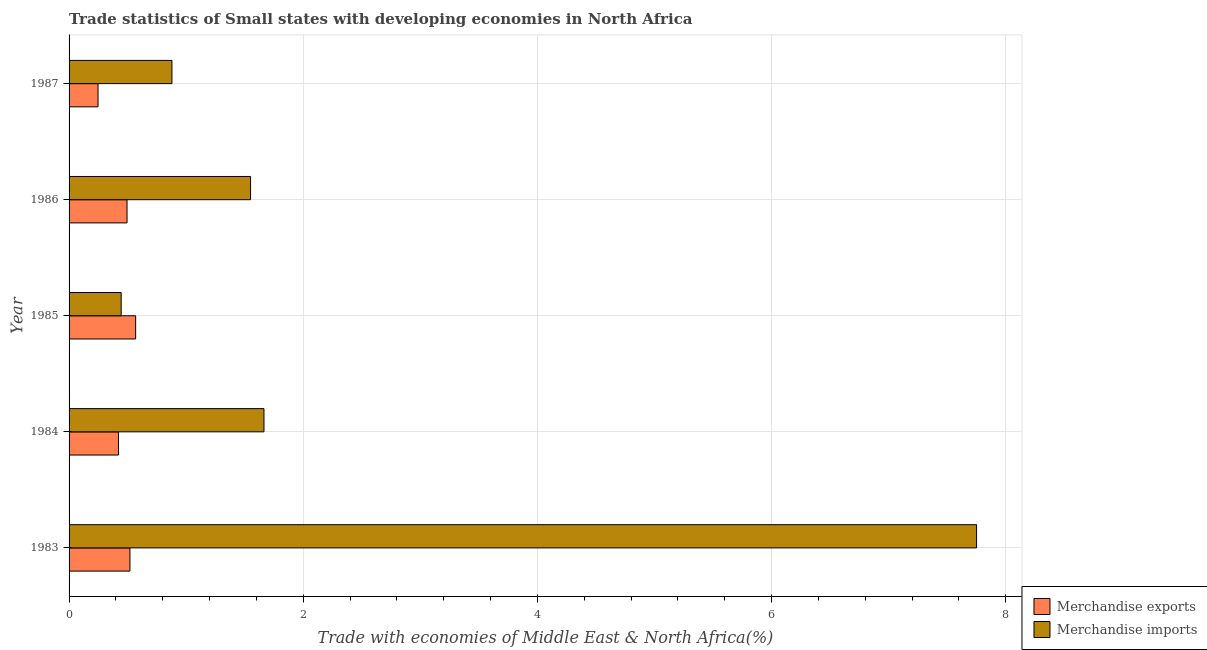How many groups of bars are there?
Offer a very short reply. 5. How many bars are there on the 2nd tick from the bottom?
Keep it short and to the point. 2. What is the label of the 4th group of bars from the top?
Ensure brevity in your answer.  1984. In how many cases, is the number of bars for a given year not equal to the number of legend labels?
Ensure brevity in your answer.  0. What is the merchandise imports in 1987?
Your answer should be compact. 0.88. Across all years, what is the maximum merchandise imports?
Your answer should be very brief. 7.75. Across all years, what is the minimum merchandise imports?
Offer a terse response. 0.45. In which year was the merchandise exports minimum?
Give a very brief answer. 1987. What is the total merchandise exports in the graph?
Your response must be concise. 2.25. What is the difference between the merchandise exports in 1984 and that in 1985?
Provide a short and direct response. -0.15. What is the difference between the merchandise imports in 1984 and the merchandise exports in 1983?
Your answer should be very brief. 1.15. What is the average merchandise exports per year?
Your answer should be very brief. 0.45. In the year 1986, what is the difference between the merchandise imports and merchandise exports?
Give a very brief answer. 1.05. In how many years, is the merchandise exports greater than 1.2000000000000002 %?
Provide a succinct answer. 0. What is the ratio of the merchandise exports in 1983 to that in 1985?
Your answer should be compact. 0.91. What is the difference between the highest and the second highest merchandise imports?
Make the answer very short. 6.09. What is the difference between the highest and the lowest merchandise imports?
Provide a succinct answer. 7.31. What does the 2nd bar from the bottom in 1984 represents?
Your answer should be very brief. Merchandise imports. How many bars are there?
Provide a short and direct response. 10. Are all the bars in the graph horizontal?
Ensure brevity in your answer.  Yes. What is the difference between two consecutive major ticks on the X-axis?
Ensure brevity in your answer.  2. Where does the legend appear in the graph?
Your answer should be very brief. Bottom right. How many legend labels are there?
Provide a short and direct response. 2. What is the title of the graph?
Offer a very short reply. Trade statistics of Small states with developing economies in North Africa. What is the label or title of the X-axis?
Offer a very short reply. Trade with economies of Middle East & North Africa(%). What is the Trade with economies of Middle East & North Africa(%) in Merchandise exports in 1983?
Make the answer very short. 0.52. What is the Trade with economies of Middle East & North Africa(%) in Merchandise imports in 1983?
Your answer should be very brief. 7.75. What is the Trade with economies of Middle East & North Africa(%) in Merchandise exports in 1984?
Your answer should be very brief. 0.42. What is the Trade with economies of Middle East & North Africa(%) of Merchandise imports in 1984?
Make the answer very short. 1.66. What is the Trade with economies of Middle East & North Africa(%) of Merchandise exports in 1985?
Ensure brevity in your answer.  0.57. What is the Trade with economies of Middle East & North Africa(%) of Merchandise imports in 1985?
Give a very brief answer. 0.45. What is the Trade with economies of Middle East & North Africa(%) in Merchandise exports in 1986?
Offer a terse response. 0.5. What is the Trade with economies of Middle East & North Africa(%) in Merchandise imports in 1986?
Your answer should be compact. 1.55. What is the Trade with economies of Middle East & North Africa(%) of Merchandise exports in 1987?
Make the answer very short. 0.25. What is the Trade with economies of Middle East & North Africa(%) in Merchandise imports in 1987?
Make the answer very short. 0.88. Across all years, what is the maximum Trade with economies of Middle East & North Africa(%) of Merchandise exports?
Offer a terse response. 0.57. Across all years, what is the maximum Trade with economies of Middle East & North Africa(%) in Merchandise imports?
Your answer should be very brief. 7.75. Across all years, what is the minimum Trade with economies of Middle East & North Africa(%) in Merchandise exports?
Your answer should be very brief. 0.25. Across all years, what is the minimum Trade with economies of Middle East & North Africa(%) in Merchandise imports?
Make the answer very short. 0.45. What is the total Trade with economies of Middle East & North Africa(%) in Merchandise exports in the graph?
Your answer should be very brief. 2.25. What is the total Trade with economies of Middle East & North Africa(%) of Merchandise imports in the graph?
Provide a short and direct response. 12.29. What is the difference between the Trade with economies of Middle East & North Africa(%) in Merchandise exports in 1983 and that in 1984?
Offer a terse response. 0.1. What is the difference between the Trade with economies of Middle East & North Africa(%) of Merchandise imports in 1983 and that in 1984?
Your answer should be compact. 6.09. What is the difference between the Trade with economies of Middle East & North Africa(%) of Merchandise exports in 1983 and that in 1985?
Provide a succinct answer. -0.05. What is the difference between the Trade with economies of Middle East & North Africa(%) in Merchandise imports in 1983 and that in 1985?
Offer a very short reply. 7.31. What is the difference between the Trade with economies of Middle East & North Africa(%) in Merchandise exports in 1983 and that in 1986?
Make the answer very short. 0.02. What is the difference between the Trade with economies of Middle East & North Africa(%) of Merchandise imports in 1983 and that in 1986?
Your answer should be compact. 6.2. What is the difference between the Trade with economies of Middle East & North Africa(%) of Merchandise exports in 1983 and that in 1987?
Give a very brief answer. 0.27. What is the difference between the Trade with economies of Middle East & North Africa(%) of Merchandise imports in 1983 and that in 1987?
Your response must be concise. 6.87. What is the difference between the Trade with economies of Middle East & North Africa(%) in Merchandise exports in 1984 and that in 1985?
Your response must be concise. -0.15. What is the difference between the Trade with economies of Middle East & North Africa(%) in Merchandise imports in 1984 and that in 1985?
Offer a terse response. 1.22. What is the difference between the Trade with economies of Middle East & North Africa(%) in Merchandise exports in 1984 and that in 1986?
Offer a very short reply. -0.07. What is the difference between the Trade with economies of Middle East & North Africa(%) in Merchandise imports in 1984 and that in 1986?
Offer a terse response. 0.11. What is the difference between the Trade with economies of Middle East & North Africa(%) of Merchandise exports in 1984 and that in 1987?
Offer a very short reply. 0.17. What is the difference between the Trade with economies of Middle East & North Africa(%) of Merchandise imports in 1984 and that in 1987?
Keep it short and to the point. 0.79. What is the difference between the Trade with economies of Middle East & North Africa(%) in Merchandise exports in 1985 and that in 1986?
Your answer should be compact. 0.07. What is the difference between the Trade with economies of Middle East & North Africa(%) in Merchandise imports in 1985 and that in 1986?
Give a very brief answer. -1.11. What is the difference between the Trade with economies of Middle East & North Africa(%) of Merchandise exports in 1985 and that in 1987?
Give a very brief answer. 0.32. What is the difference between the Trade with economies of Middle East & North Africa(%) in Merchandise imports in 1985 and that in 1987?
Your answer should be very brief. -0.43. What is the difference between the Trade with economies of Middle East & North Africa(%) of Merchandise exports in 1986 and that in 1987?
Make the answer very short. 0.25. What is the difference between the Trade with economies of Middle East & North Africa(%) of Merchandise imports in 1986 and that in 1987?
Ensure brevity in your answer.  0.67. What is the difference between the Trade with economies of Middle East & North Africa(%) of Merchandise exports in 1983 and the Trade with economies of Middle East & North Africa(%) of Merchandise imports in 1984?
Offer a terse response. -1.15. What is the difference between the Trade with economies of Middle East & North Africa(%) in Merchandise exports in 1983 and the Trade with economies of Middle East & North Africa(%) in Merchandise imports in 1985?
Your answer should be very brief. 0.07. What is the difference between the Trade with economies of Middle East & North Africa(%) of Merchandise exports in 1983 and the Trade with economies of Middle East & North Africa(%) of Merchandise imports in 1986?
Your answer should be compact. -1.03. What is the difference between the Trade with economies of Middle East & North Africa(%) of Merchandise exports in 1983 and the Trade with economies of Middle East & North Africa(%) of Merchandise imports in 1987?
Provide a short and direct response. -0.36. What is the difference between the Trade with economies of Middle East & North Africa(%) of Merchandise exports in 1984 and the Trade with economies of Middle East & North Africa(%) of Merchandise imports in 1985?
Your response must be concise. -0.02. What is the difference between the Trade with economies of Middle East & North Africa(%) in Merchandise exports in 1984 and the Trade with economies of Middle East & North Africa(%) in Merchandise imports in 1986?
Provide a short and direct response. -1.13. What is the difference between the Trade with economies of Middle East & North Africa(%) of Merchandise exports in 1984 and the Trade with economies of Middle East & North Africa(%) of Merchandise imports in 1987?
Make the answer very short. -0.46. What is the difference between the Trade with economies of Middle East & North Africa(%) in Merchandise exports in 1985 and the Trade with economies of Middle East & North Africa(%) in Merchandise imports in 1986?
Provide a short and direct response. -0.98. What is the difference between the Trade with economies of Middle East & North Africa(%) of Merchandise exports in 1985 and the Trade with economies of Middle East & North Africa(%) of Merchandise imports in 1987?
Ensure brevity in your answer.  -0.31. What is the difference between the Trade with economies of Middle East & North Africa(%) of Merchandise exports in 1986 and the Trade with economies of Middle East & North Africa(%) of Merchandise imports in 1987?
Provide a short and direct response. -0.38. What is the average Trade with economies of Middle East & North Africa(%) in Merchandise exports per year?
Your answer should be compact. 0.45. What is the average Trade with economies of Middle East & North Africa(%) in Merchandise imports per year?
Provide a short and direct response. 2.46. In the year 1983, what is the difference between the Trade with economies of Middle East & North Africa(%) of Merchandise exports and Trade with economies of Middle East & North Africa(%) of Merchandise imports?
Provide a short and direct response. -7.23. In the year 1984, what is the difference between the Trade with economies of Middle East & North Africa(%) in Merchandise exports and Trade with economies of Middle East & North Africa(%) in Merchandise imports?
Offer a terse response. -1.24. In the year 1985, what is the difference between the Trade with economies of Middle East & North Africa(%) of Merchandise exports and Trade with economies of Middle East & North Africa(%) of Merchandise imports?
Your answer should be very brief. 0.12. In the year 1986, what is the difference between the Trade with economies of Middle East & North Africa(%) of Merchandise exports and Trade with economies of Middle East & North Africa(%) of Merchandise imports?
Offer a very short reply. -1.06. In the year 1987, what is the difference between the Trade with economies of Middle East & North Africa(%) in Merchandise exports and Trade with economies of Middle East & North Africa(%) in Merchandise imports?
Offer a very short reply. -0.63. What is the ratio of the Trade with economies of Middle East & North Africa(%) in Merchandise exports in 1983 to that in 1984?
Your answer should be very brief. 1.23. What is the ratio of the Trade with economies of Middle East & North Africa(%) in Merchandise imports in 1983 to that in 1984?
Make the answer very short. 4.66. What is the ratio of the Trade with economies of Middle East & North Africa(%) in Merchandise exports in 1983 to that in 1985?
Provide a succinct answer. 0.91. What is the ratio of the Trade with economies of Middle East & North Africa(%) of Merchandise imports in 1983 to that in 1985?
Provide a short and direct response. 17.41. What is the ratio of the Trade with economies of Middle East & North Africa(%) in Merchandise imports in 1983 to that in 1986?
Your response must be concise. 5. What is the ratio of the Trade with economies of Middle East & North Africa(%) in Merchandise exports in 1983 to that in 1987?
Give a very brief answer. 2.1. What is the ratio of the Trade with economies of Middle East & North Africa(%) of Merchandise imports in 1983 to that in 1987?
Offer a very short reply. 8.82. What is the ratio of the Trade with economies of Middle East & North Africa(%) in Merchandise exports in 1984 to that in 1985?
Ensure brevity in your answer.  0.74. What is the ratio of the Trade with economies of Middle East & North Africa(%) of Merchandise imports in 1984 to that in 1985?
Your response must be concise. 3.74. What is the ratio of the Trade with economies of Middle East & North Africa(%) of Merchandise exports in 1984 to that in 1986?
Provide a succinct answer. 0.85. What is the ratio of the Trade with economies of Middle East & North Africa(%) of Merchandise imports in 1984 to that in 1986?
Offer a terse response. 1.07. What is the ratio of the Trade with economies of Middle East & North Africa(%) in Merchandise exports in 1984 to that in 1987?
Offer a terse response. 1.71. What is the ratio of the Trade with economies of Middle East & North Africa(%) of Merchandise imports in 1984 to that in 1987?
Keep it short and to the point. 1.89. What is the ratio of the Trade with economies of Middle East & North Africa(%) in Merchandise exports in 1985 to that in 1986?
Provide a short and direct response. 1.15. What is the ratio of the Trade with economies of Middle East & North Africa(%) in Merchandise imports in 1985 to that in 1986?
Your response must be concise. 0.29. What is the ratio of the Trade with economies of Middle East & North Africa(%) of Merchandise exports in 1985 to that in 1987?
Provide a succinct answer. 2.3. What is the ratio of the Trade with economies of Middle East & North Africa(%) in Merchandise imports in 1985 to that in 1987?
Offer a very short reply. 0.51. What is the ratio of the Trade with economies of Middle East & North Africa(%) of Merchandise exports in 1986 to that in 1987?
Your answer should be very brief. 2. What is the ratio of the Trade with economies of Middle East & North Africa(%) of Merchandise imports in 1986 to that in 1987?
Make the answer very short. 1.76. What is the difference between the highest and the second highest Trade with economies of Middle East & North Africa(%) of Merchandise exports?
Your answer should be compact. 0.05. What is the difference between the highest and the second highest Trade with economies of Middle East & North Africa(%) of Merchandise imports?
Provide a short and direct response. 6.09. What is the difference between the highest and the lowest Trade with economies of Middle East & North Africa(%) in Merchandise exports?
Provide a short and direct response. 0.32. What is the difference between the highest and the lowest Trade with economies of Middle East & North Africa(%) in Merchandise imports?
Keep it short and to the point. 7.31. 